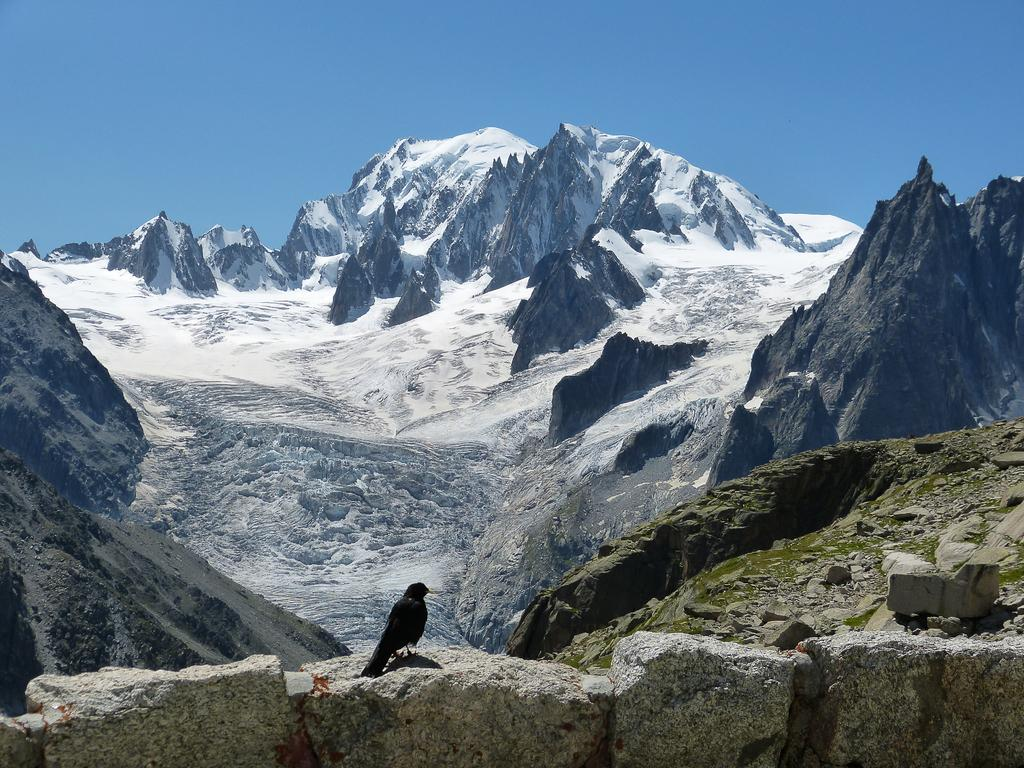What type of bird is on the rock in the image? There is a black color bird on a rock in the image. How is the rock positioned in relation to other rocks? The rock is attached to other rocks. What can be seen in the background of the image? There are snow mountains in the background of the image. What is the color of the sky in the image? The sky is blue in the image. What design can be seen on the bird's toe in the image? There is no mention of a bird's toe or any design on it in the provided facts, so we cannot answer this question. 